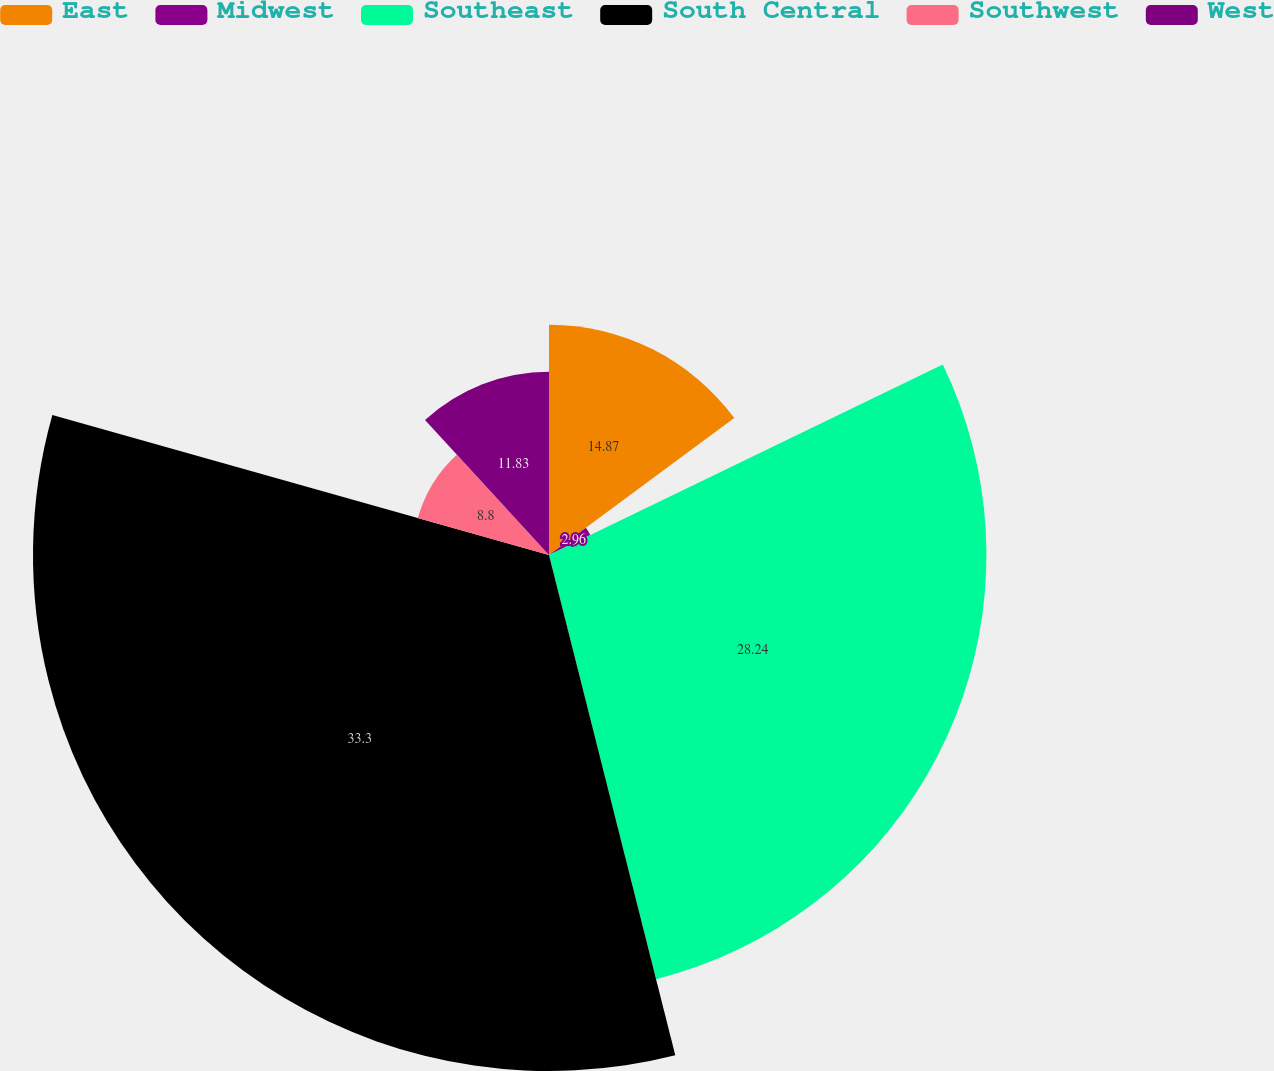<chart> <loc_0><loc_0><loc_500><loc_500><pie_chart><fcel>East<fcel>Midwest<fcel>Southeast<fcel>South Central<fcel>Southwest<fcel>West<nl><fcel>14.87%<fcel>2.96%<fcel>28.24%<fcel>33.31%<fcel>8.8%<fcel>11.83%<nl></chart> 